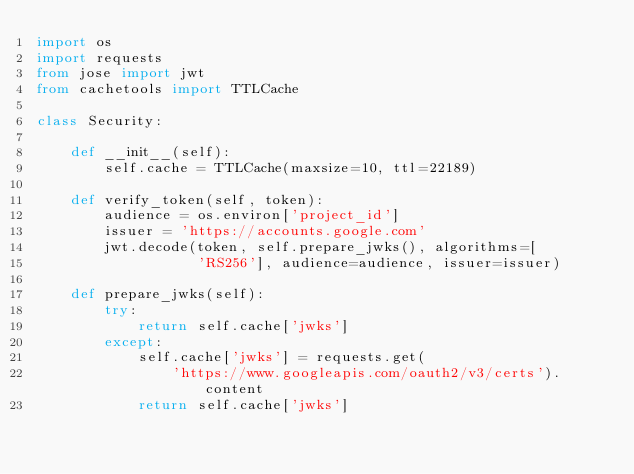<code> <loc_0><loc_0><loc_500><loc_500><_Python_>import os
import requests
from jose import jwt
from cachetools import TTLCache

class Security:

    def __init__(self):
        self.cache = TTLCache(maxsize=10, ttl=22189)

    def verify_token(self, token):
        audience = os.environ['project_id']
        issuer = 'https://accounts.google.com'
        jwt.decode(token, self.prepare_jwks(), algorithms=[
                   'RS256'], audience=audience, issuer=issuer)

    def prepare_jwks(self):
        try:
            return self.cache['jwks']
        except:
            self.cache['jwks'] = requests.get(
                'https://www.googleapis.com/oauth2/v3/certs').content
            return self.cache['jwks']
</code> 